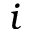<formula> <loc_0><loc_0><loc_500><loc_500>i</formula> 